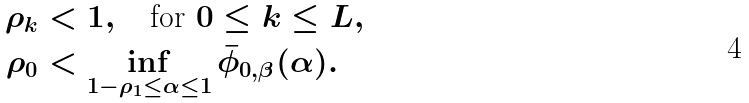<formula> <loc_0><loc_0><loc_500><loc_500>\rho _ { k } & < 1 , \quad \text {for } 0 \leq k \leq L , \\ \rho _ { 0 } & < \inf _ { 1 - \rho _ { 1 } \leq \alpha \leq 1 } \bar { \phi } _ { 0 , \beta } ( \alpha ) .</formula> 